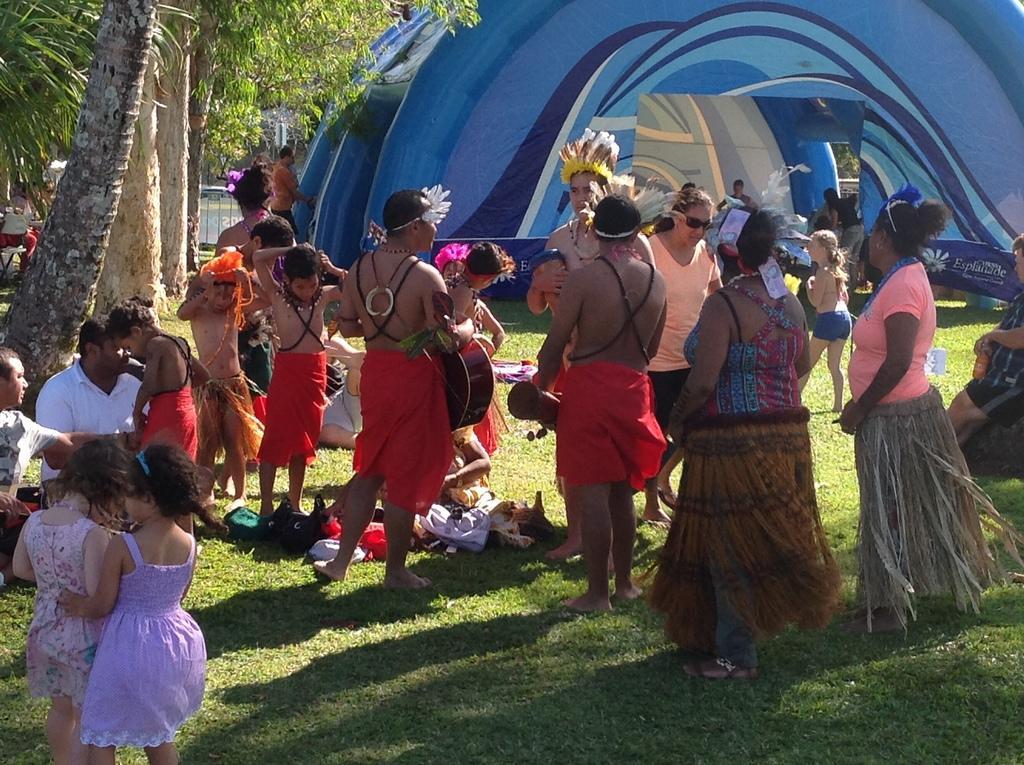How would you summarize this image in a sentence or two? In this image we can see some persons standing on the grass and some persons sitting on the grass. In the background we can see tent, iron grill and trees. 